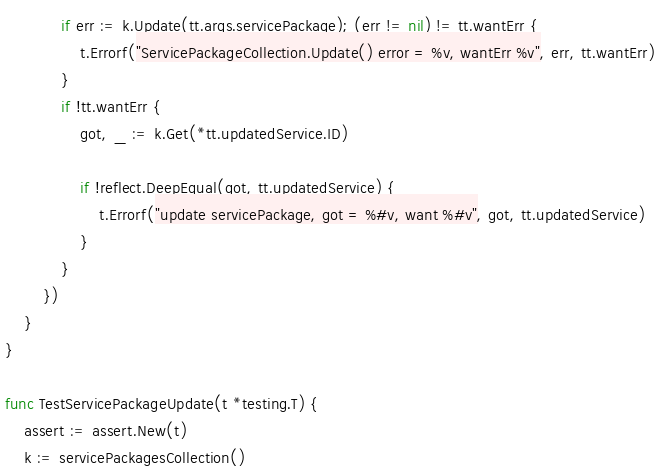Convert code to text. <code><loc_0><loc_0><loc_500><loc_500><_Go_>			if err := k.Update(tt.args.servicePackage); (err != nil) != tt.wantErr {
				t.Errorf("ServicePackageCollection.Update() error = %v, wantErr %v", err, tt.wantErr)
			}
			if !tt.wantErr {
				got, _ := k.Get(*tt.updatedService.ID)

				if !reflect.DeepEqual(got, tt.updatedService) {
					t.Errorf("update servicePackage, got = %#v, want %#v", got, tt.updatedService)
				}
			}
		})
	}
}

func TestServicePackageUpdate(t *testing.T) {
	assert := assert.New(t)
	k := servicePackagesCollection()</code> 